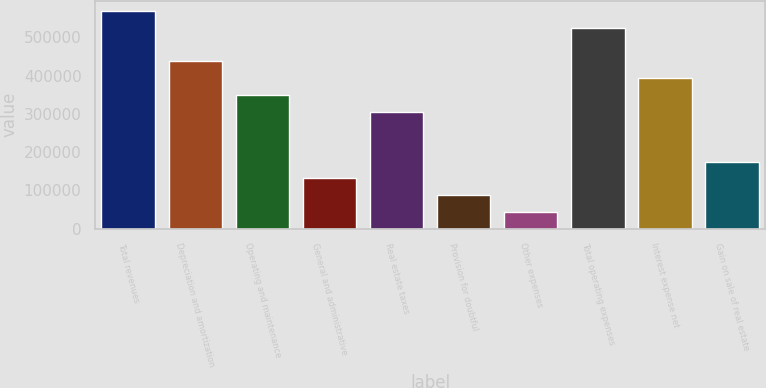<chart> <loc_0><loc_0><loc_500><loc_500><bar_chart><fcel>Total revenues<fcel>Depreciation and amortization<fcel>Operating and maintenance<fcel>General and administrative<fcel>Real estate taxes<fcel>Provision for doubtful<fcel>Other expenses<fcel>Total operating expenses<fcel>Interest expense net<fcel>Gain on sale of real estate<nl><fcel>568023<fcel>437029<fcel>349700<fcel>131377<fcel>306035<fcel>87712.2<fcel>44047.6<fcel>524358<fcel>393364<fcel>175041<nl></chart> 